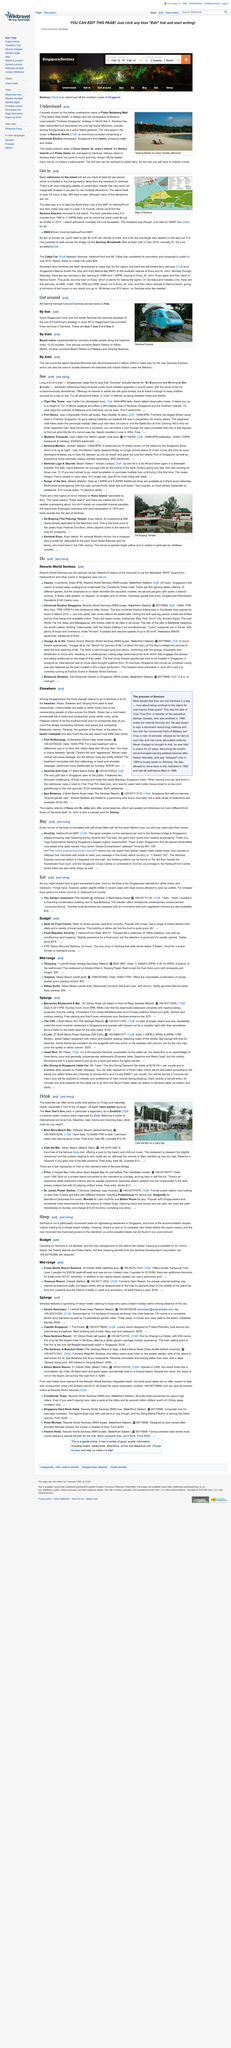Mention a couple of crucial points in this snapshot. Camping is not allowed on Sentosa. Bora Bora Beach Bar opens daily at 10:30 AM and closes at 7 PM or later. ZoukOut is an annual outdoor party organized by Zouk, attracting a diverse lineup of world-renowned DJs and drawing a large crowd of music enthusiasts from all over the world. There is a service that connects Beach Station to Siloso Beach. The dress code at the casino prohibits the wearing of slippers, singlets, and shorts. 